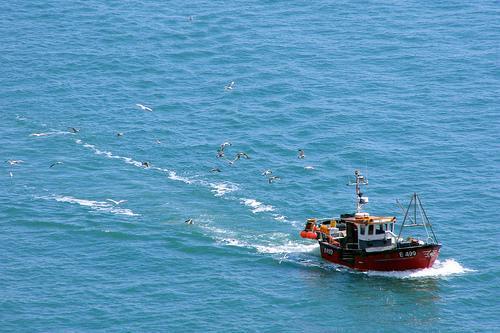How many boats are in the water?
Give a very brief answer. 1. 